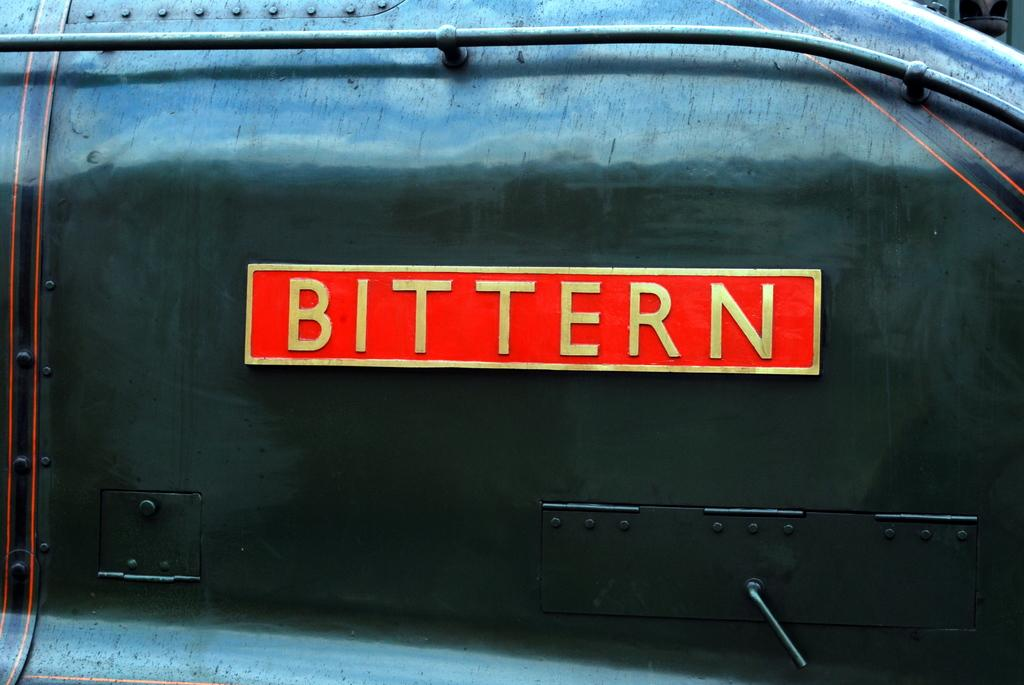<image>
Create a compact narrative representing the image presented. A gold and red sign with the word Bittern on it. 